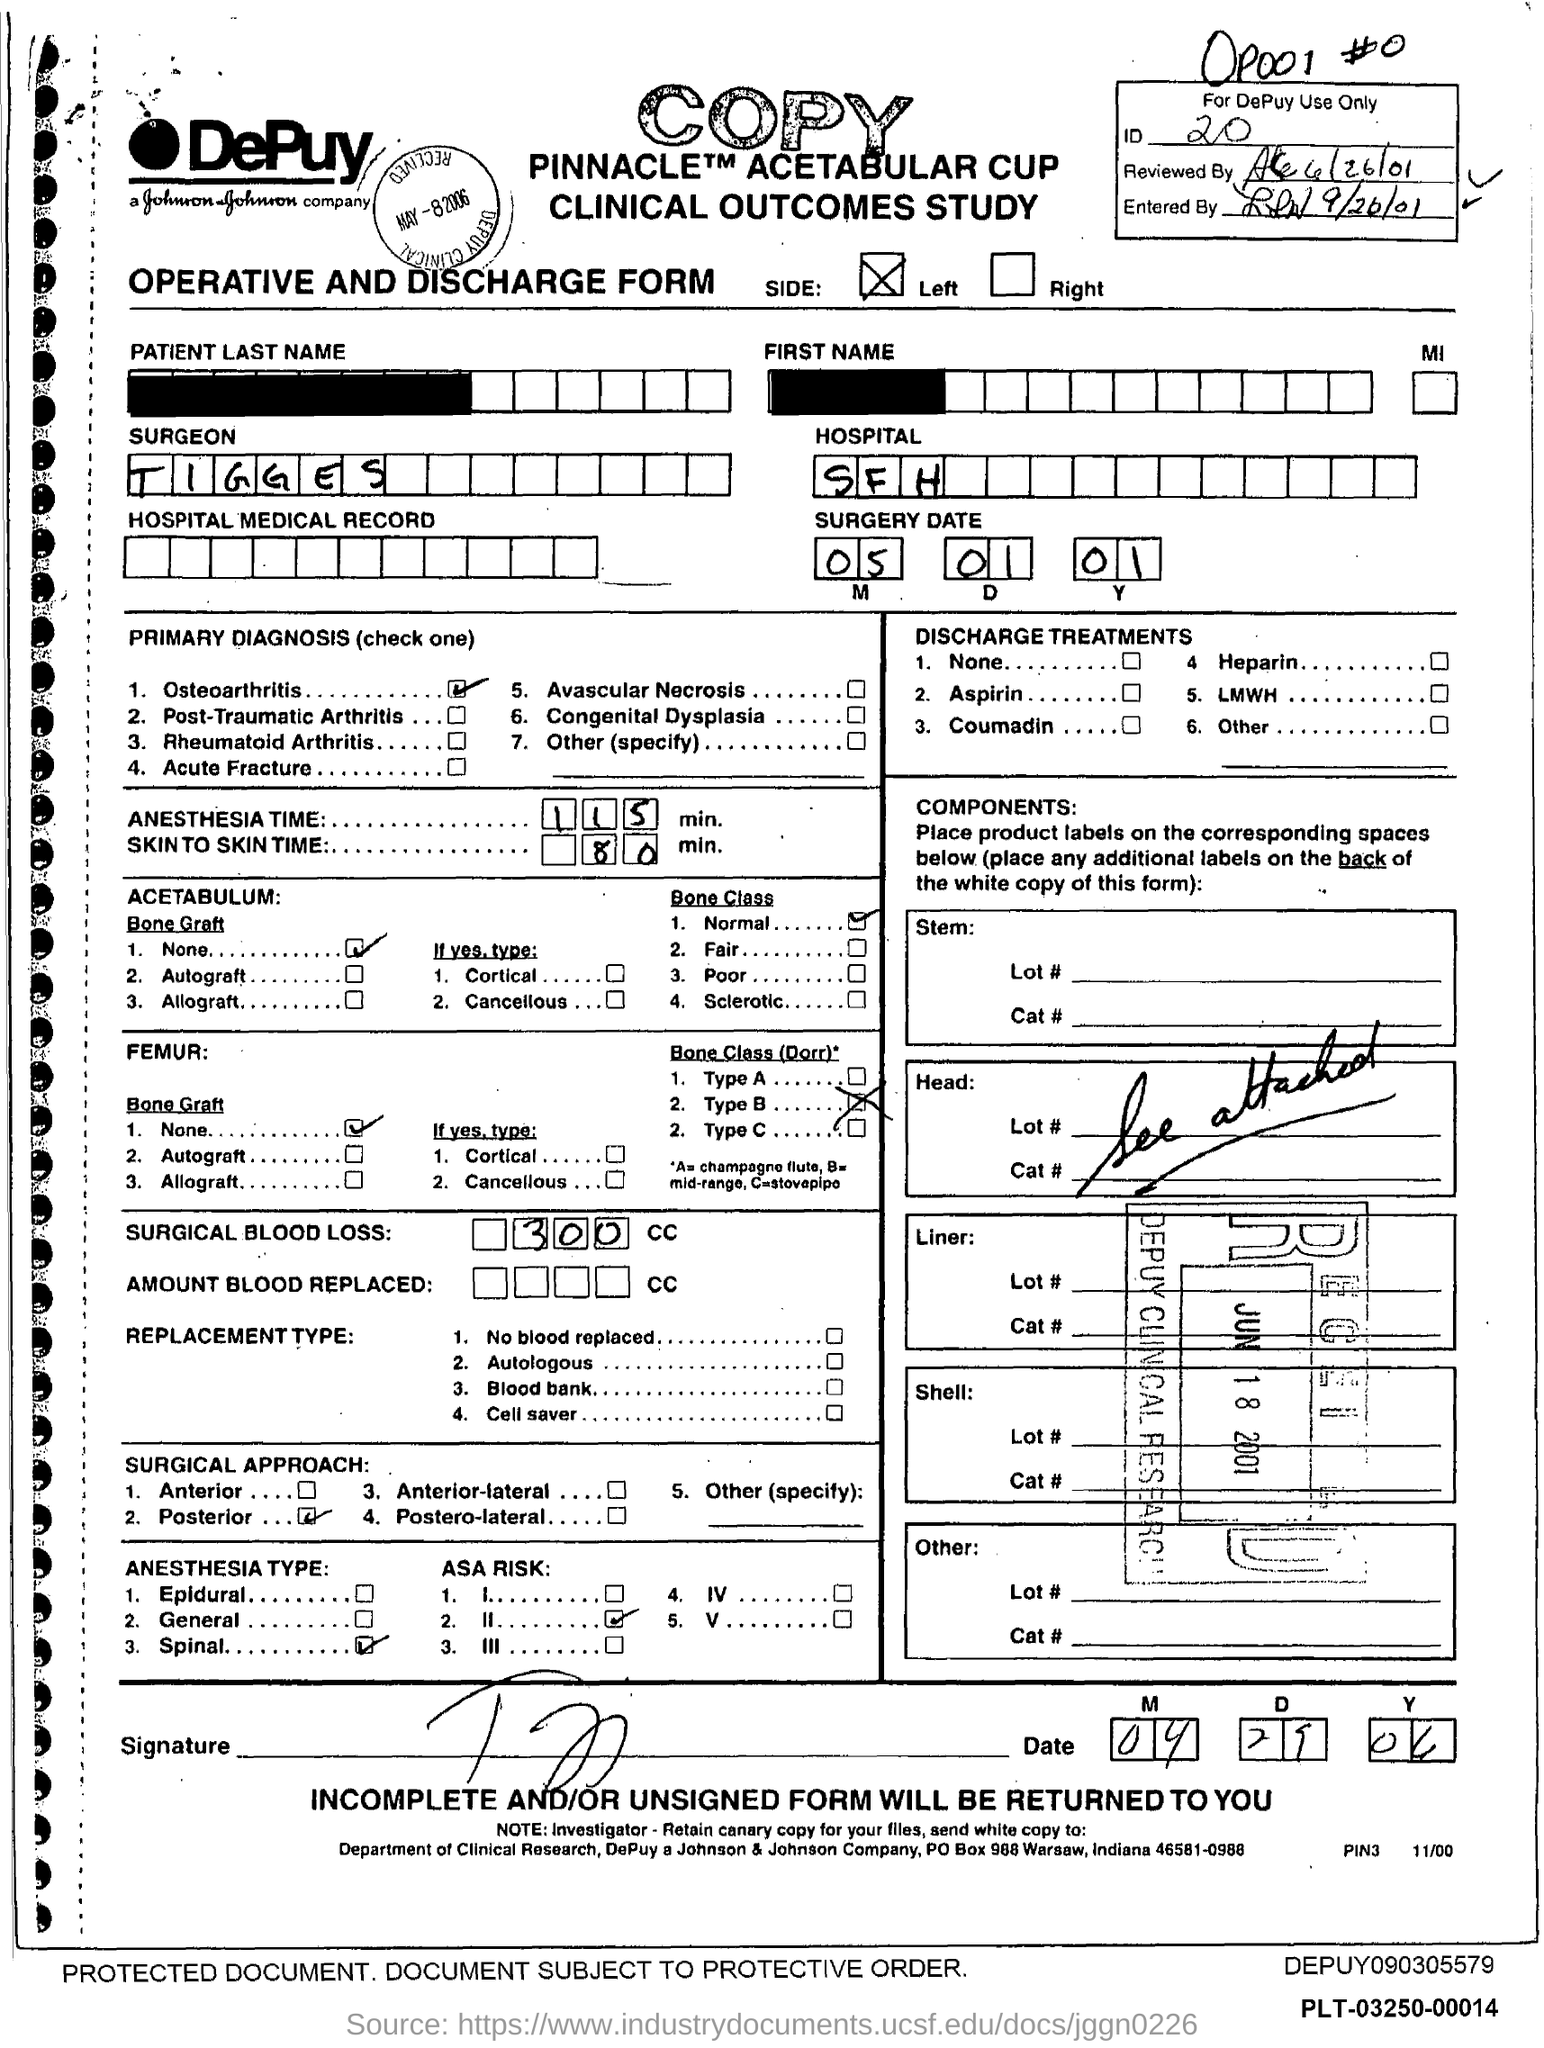What type of form is given here?
Provide a short and direct response. Operative and Discharge Form. What is the ID mentioned in the form?
Your answer should be compact. 20. What is the surgery date mentioned in the form?
Offer a terse response. 05 01 01. What is the surgeon's name given in the form?
Offer a very short reply. TIGGES. In which hospital is the surgery done?
Make the answer very short. SFH. What is the primary diagnosis of the surgery?
Offer a very short reply. Osteoarthritis. What is the anesthesia time for the surgery?
Give a very brief answer. 115 min. What is the skin to skin time for the surgery?
Make the answer very short. 80 min. What is the amount of surgical blood loss?
Your answer should be very brief. 300 CC. Which surgical approach is used for the surgery?
Give a very brief answer. Posterior. 